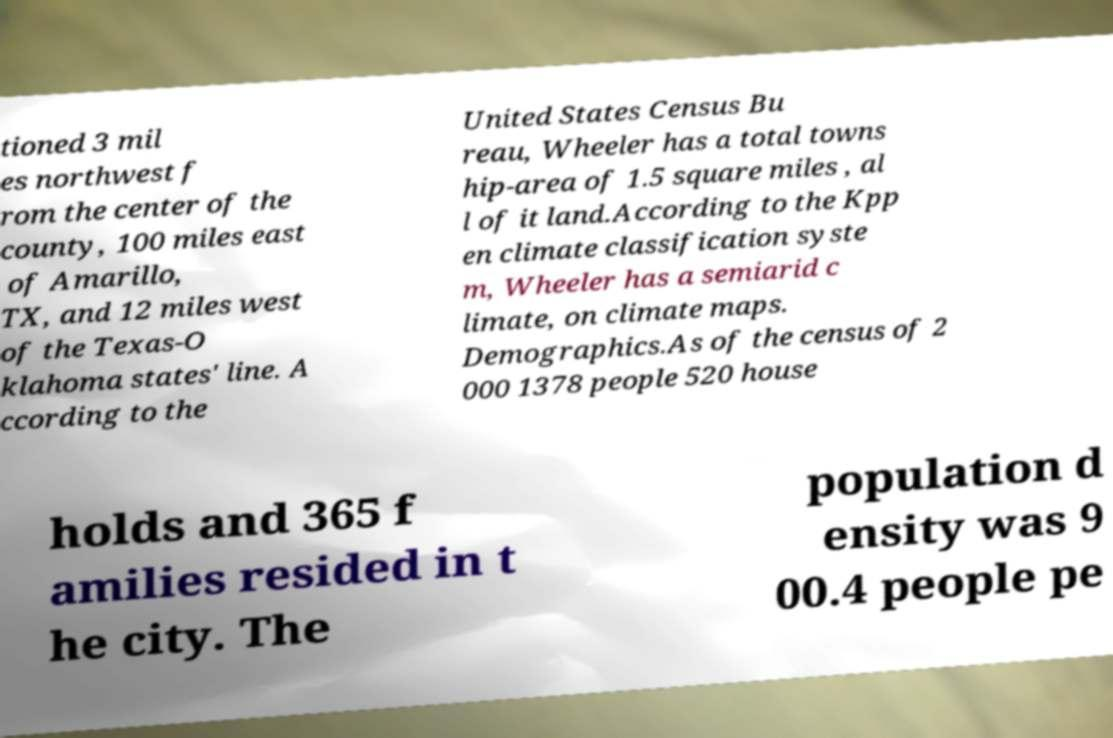Please read and relay the text visible in this image. What does it say? tioned 3 mil es northwest f rom the center of the county, 100 miles east of Amarillo, TX, and 12 miles west of the Texas-O klahoma states' line. A ccording to the United States Census Bu reau, Wheeler has a total towns hip-area of 1.5 square miles , al l of it land.According to the Kpp en climate classification syste m, Wheeler has a semiarid c limate, on climate maps. Demographics.As of the census of 2 000 1378 people 520 house holds and 365 f amilies resided in t he city. The population d ensity was 9 00.4 people pe 